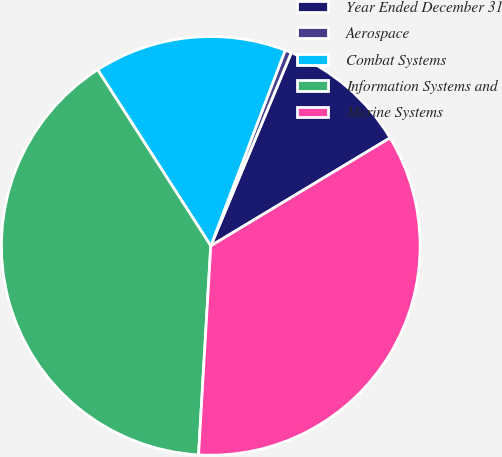Convert chart. <chart><loc_0><loc_0><loc_500><loc_500><pie_chart><fcel>Year Ended December 31<fcel>Aerospace<fcel>Combat Systems<fcel>Information Systems and<fcel>Marine Systems<nl><fcel>10.09%<fcel>0.5%<fcel>14.87%<fcel>39.99%<fcel>34.56%<nl></chart> 